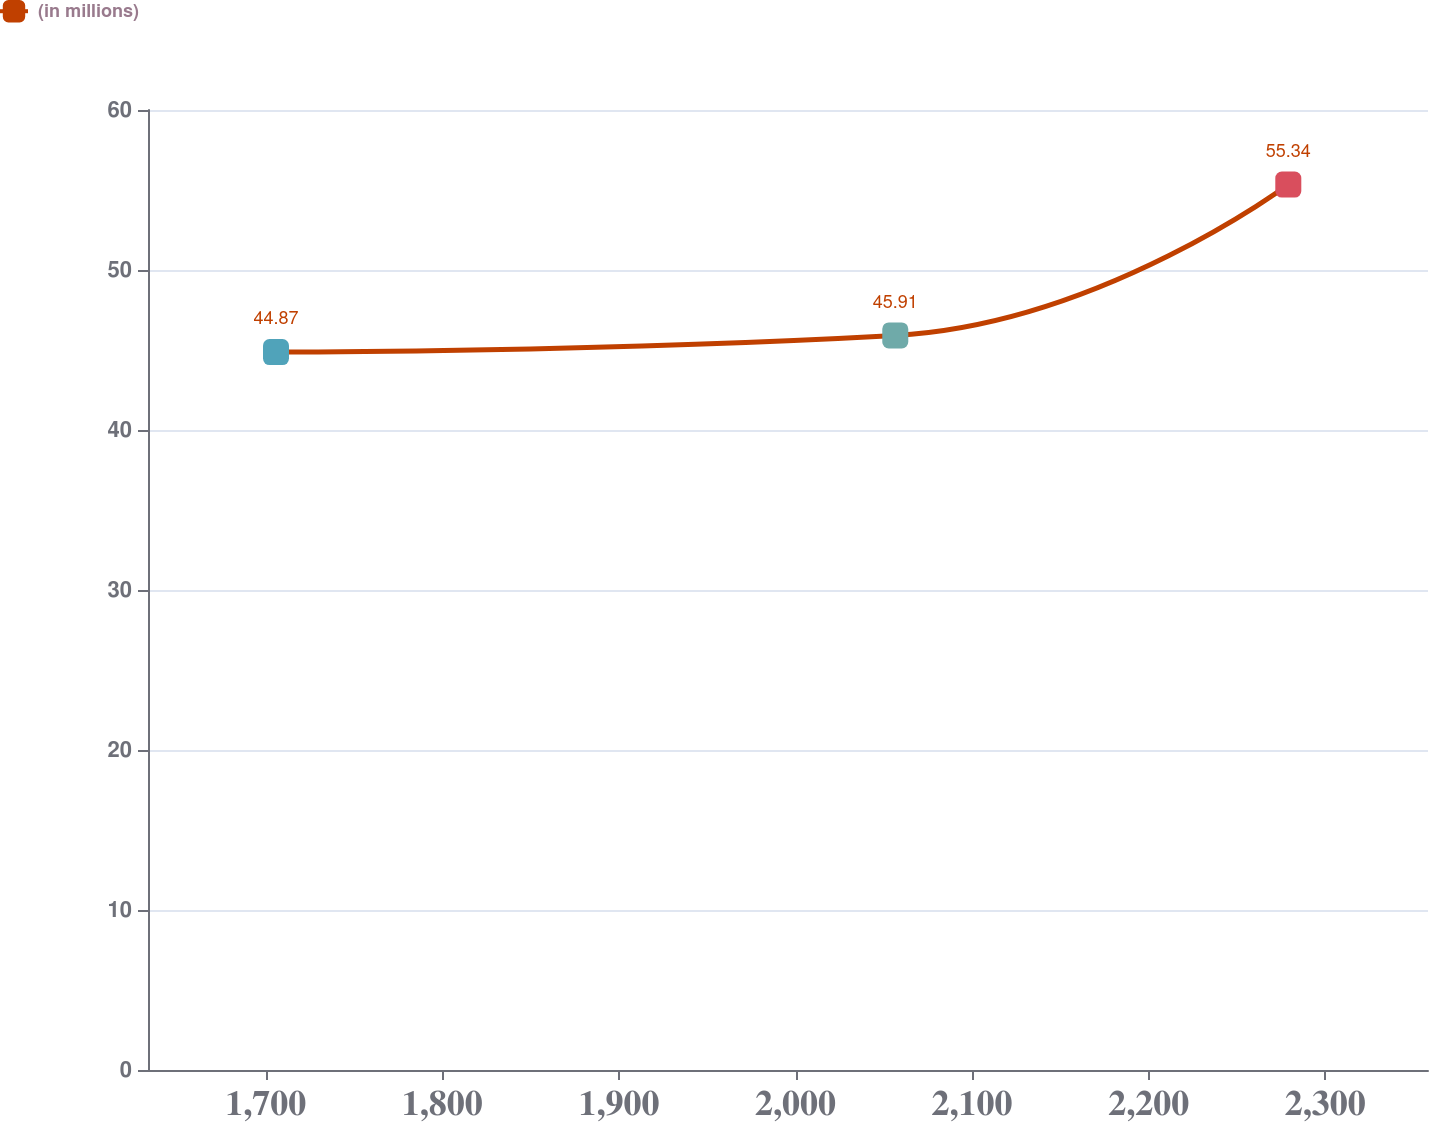<chart> <loc_0><loc_0><loc_500><loc_500><line_chart><ecel><fcel>(in millions)<nl><fcel>1705.79<fcel>44.87<nl><fcel>2056.49<fcel>45.91<nl><fcel>2279.06<fcel>55.34<nl><fcel>2360.9<fcel>54.3<nl><fcel>2430.66<fcel>53.26<nl></chart> 